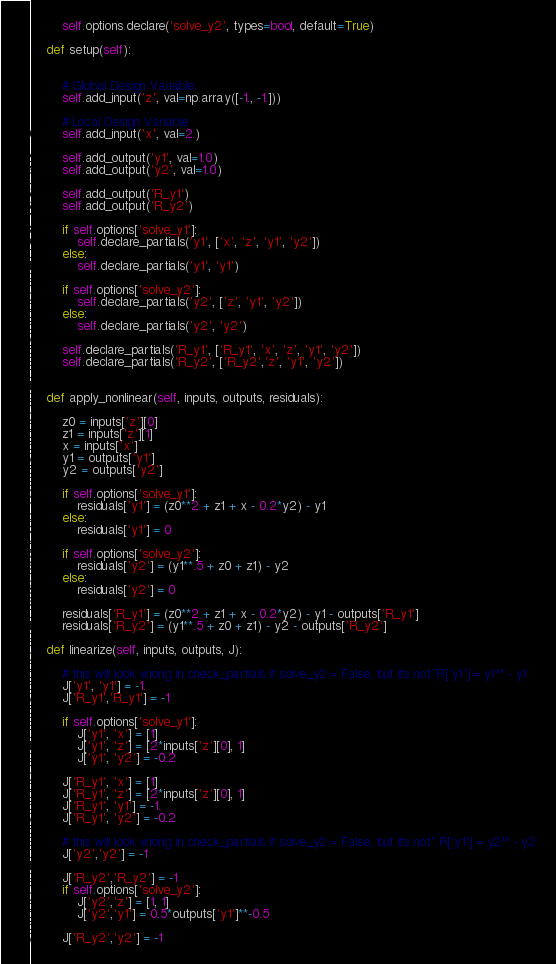Convert code to text. <code><loc_0><loc_0><loc_500><loc_500><_Python_>        self.options.declare('solve_y2', types=bool, default=True)

    def setup(self):


        # Global Design Variable
        self.add_input('z', val=np.array([-1., -1.]))

        # Local Design Variable
        self.add_input('x', val=2.)

        self.add_output('y1', val=1.0)
        self.add_output('y2', val=1.0)

        self.add_output('R_y1')
        self.add_output('R_y2')

        if self.options['solve_y1']:
            self.declare_partials('y1', ['x', 'z', 'y1', 'y2'])
        else:
            self.declare_partials('y1', 'y1')

        if self.options['solve_y2']:
            self.declare_partials('y2', ['z', 'y1', 'y2'])
        else:
            self.declare_partials('y2', 'y2')

        self.declare_partials('R_y1', ['R_y1', 'x', 'z', 'y1', 'y2'])
        self.declare_partials('R_y2', ['R_y2','z', 'y1', 'y2'])


    def apply_nonlinear(self, inputs, outputs, residuals):

        z0 = inputs['z'][0]
        z1 = inputs['z'][1]
        x = inputs['x']
        y1 = outputs['y1']
        y2 = outputs['y2']

        if self.options['solve_y1']:
            residuals['y1'] = (z0**2 + z1 + x - 0.2*y2) - y1
        else:
            residuals['y1'] = 0

        if self.options['solve_y2']:
            residuals['y2'] = (y1**.5 + z0 + z1) - y2
        else:
            residuals['y2'] = 0

        residuals['R_y1'] = (z0**2 + z1 + x - 0.2*y2) - y1 - outputs['R_y1']
        residuals['R_y2'] = (y1**.5 + z0 + z1) - y2 - outputs['R_y2']

    def linearize(self, inputs, outputs, J):

        # this will look wrong in check_partials if solve_y2 = False, but its not: R['y1'] = y1^* - y1
        J['y1', 'y1'] = -1.
        J['R_y1','R_y1'] = -1

        if self.options['solve_y1']:
            J['y1', 'x'] = [1]
            J['y1', 'z'] = [2*inputs['z'][0], 1]
            J['y1', 'y2'] = -0.2

        J['R_y1', 'x'] = [1]
        J['R_y1', 'z'] = [2*inputs['z'][0], 1]
        J['R_y1', 'y1'] = -1.
        J['R_y1', 'y2'] = -0.2

        # this will look wrong in check_partials if solve_y2 = False, but its not" R['y1'] = y2^* - y2
        J['y2','y2'] = -1

        J['R_y2','R_y2'] = -1
        if self.options['solve_y2']:
            J['y2','z'] = [1, 1]
            J['y2','y1'] = 0.5*outputs['y1']**-0.5

        J['R_y2','y2'] = -1</code> 